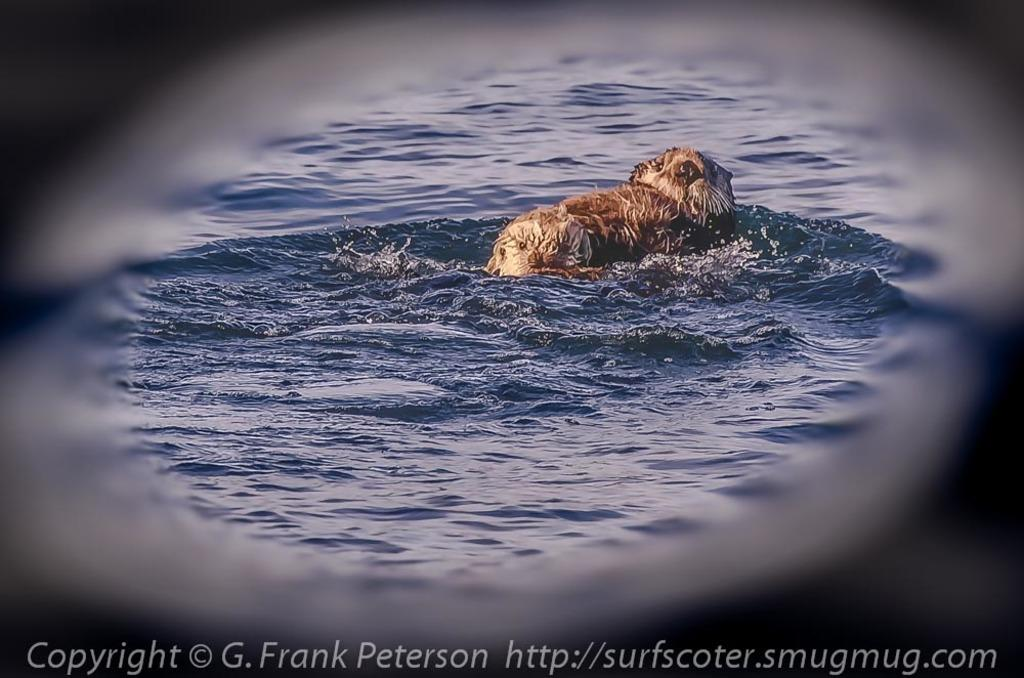What is the primary element in the image? The image contains water. Is there any animal present in the water? Yes, there is a dog in the water. Can you describe the overall appearance of the image? The edges of the picture are blurred. What type of apparel is the boy wearing in the image? There is no boy present in the image; it features a dog in the water. Which leg of the dog is visible in the image? The image does not show a specific leg of the dog; it only shows the dog swimming in the water. 